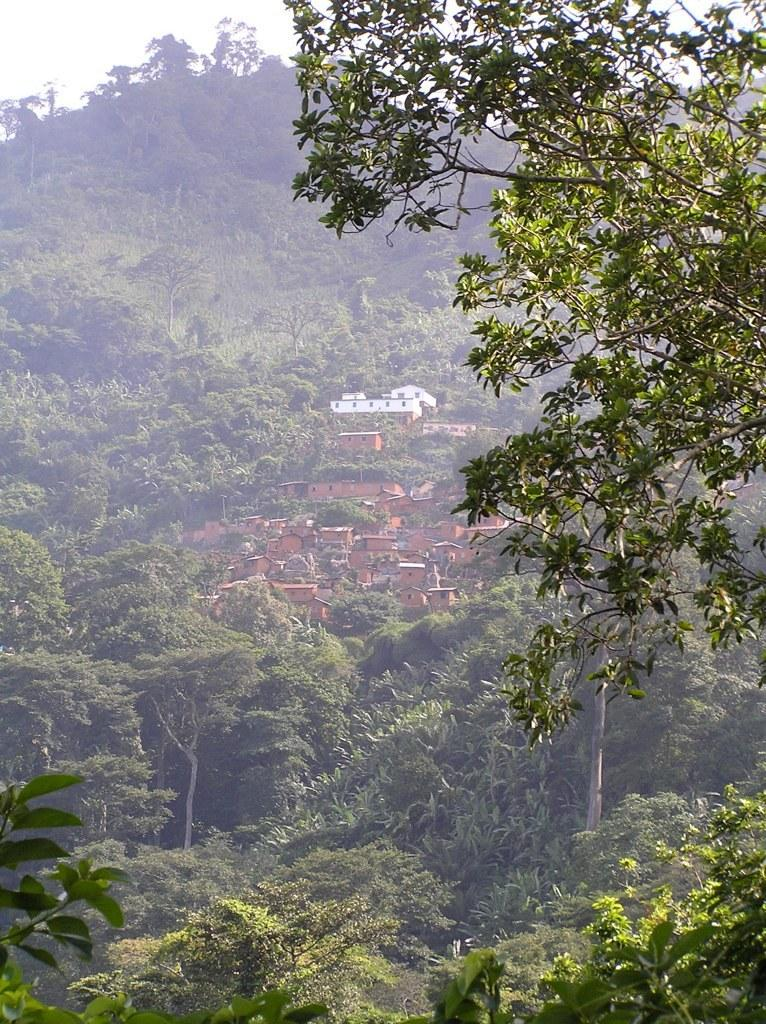What type of natural vegetation can be seen in the image? There are trees in the image. What type of man-made structures are present in the image? There are buildings in the image. What type of glass objects can be seen hanging from the trees in the image? There is no glass object present in the image, as it only features trees and buildings. What type of cloth is draped over the buildings in the image? There is no cloth draped over the buildings in the image; only trees and buildings are present. 